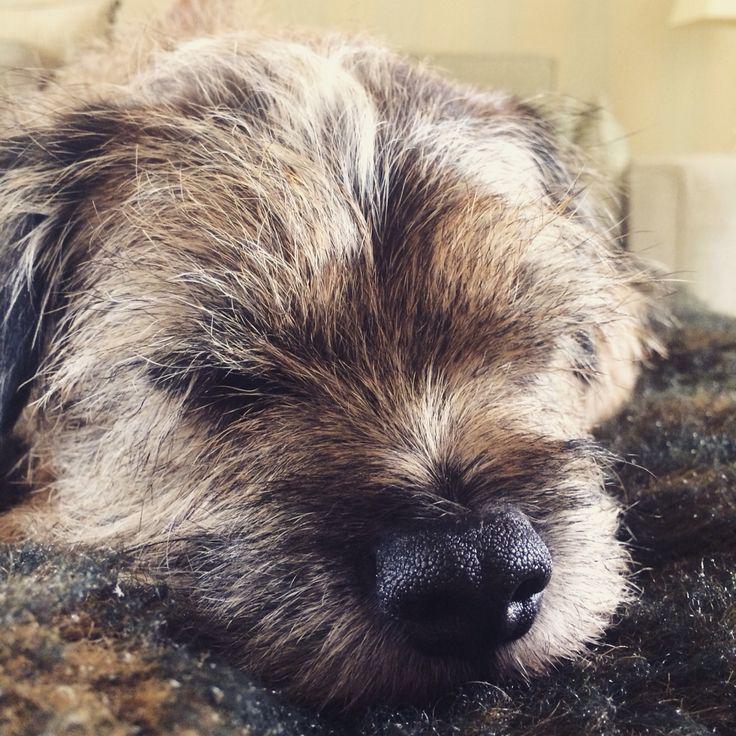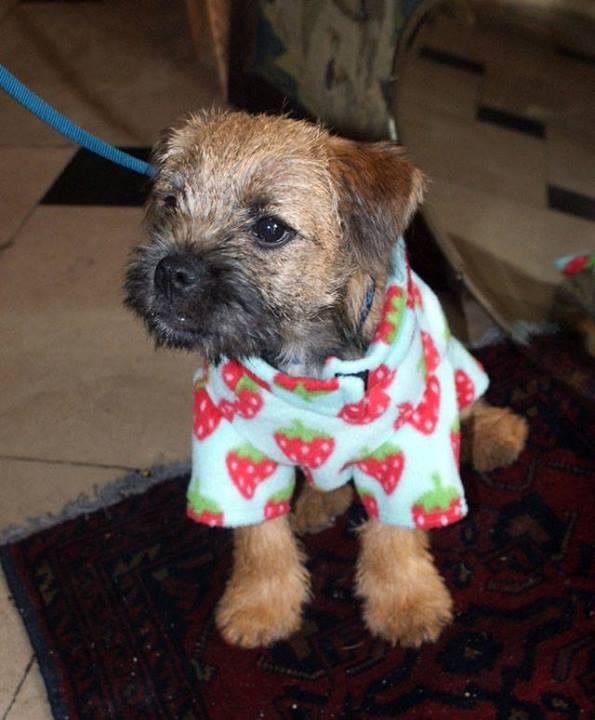The first image is the image on the left, the second image is the image on the right. Analyze the images presented: Is the assertion "One dog is wearing an article of clothing." valid? Answer yes or no. Yes. The first image is the image on the left, the second image is the image on the right. Analyze the images presented: Is the assertion "One little dog is wearing a clothing prop." valid? Answer yes or no. Yes. 